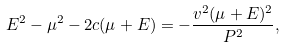Convert formula to latex. <formula><loc_0><loc_0><loc_500><loc_500>E ^ { 2 } - \mu ^ { 2 } - 2 c ( \mu + E ) = - \frac { v ^ { 2 } ( \mu + E ) ^ { 2 } } { P ^ { 2 } } ,</formula> 